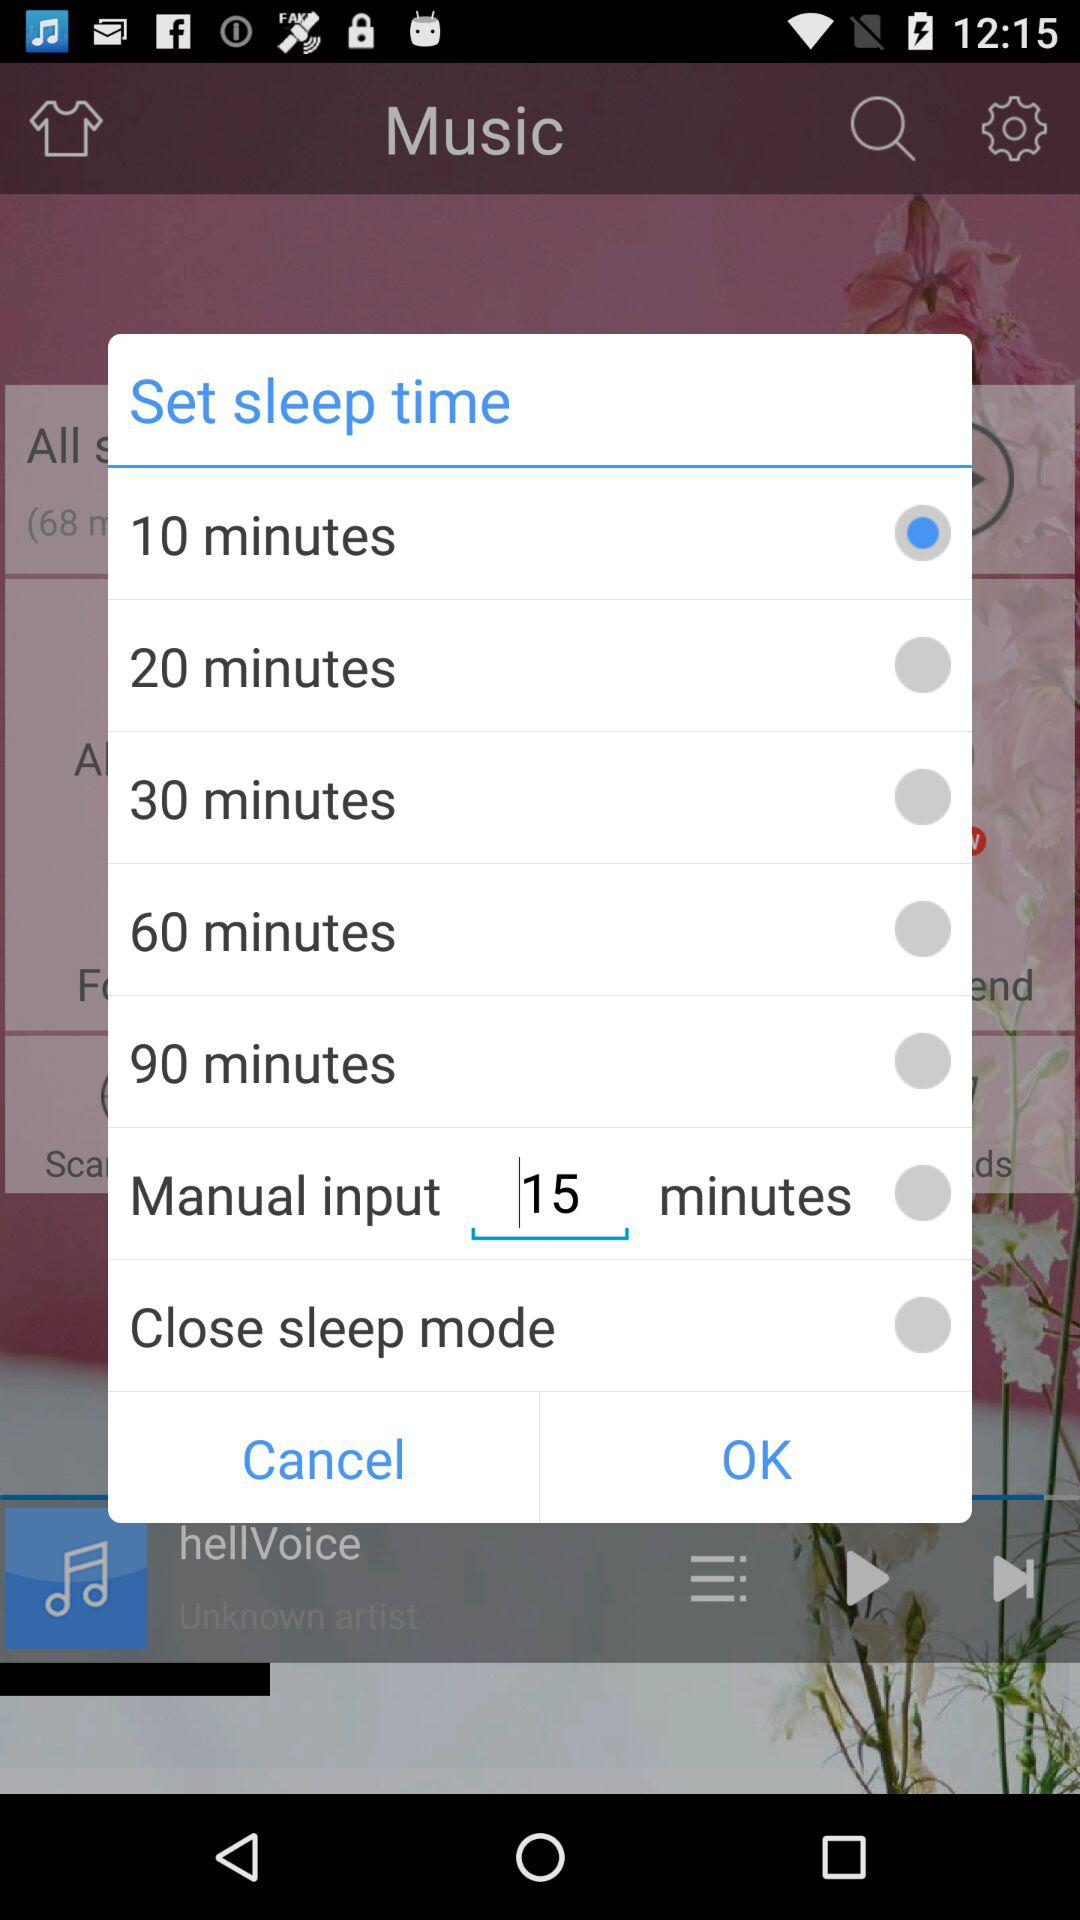How many minutes is the shortest sleep time available?
Answer the question using a single word or phrase. 10 minutes 